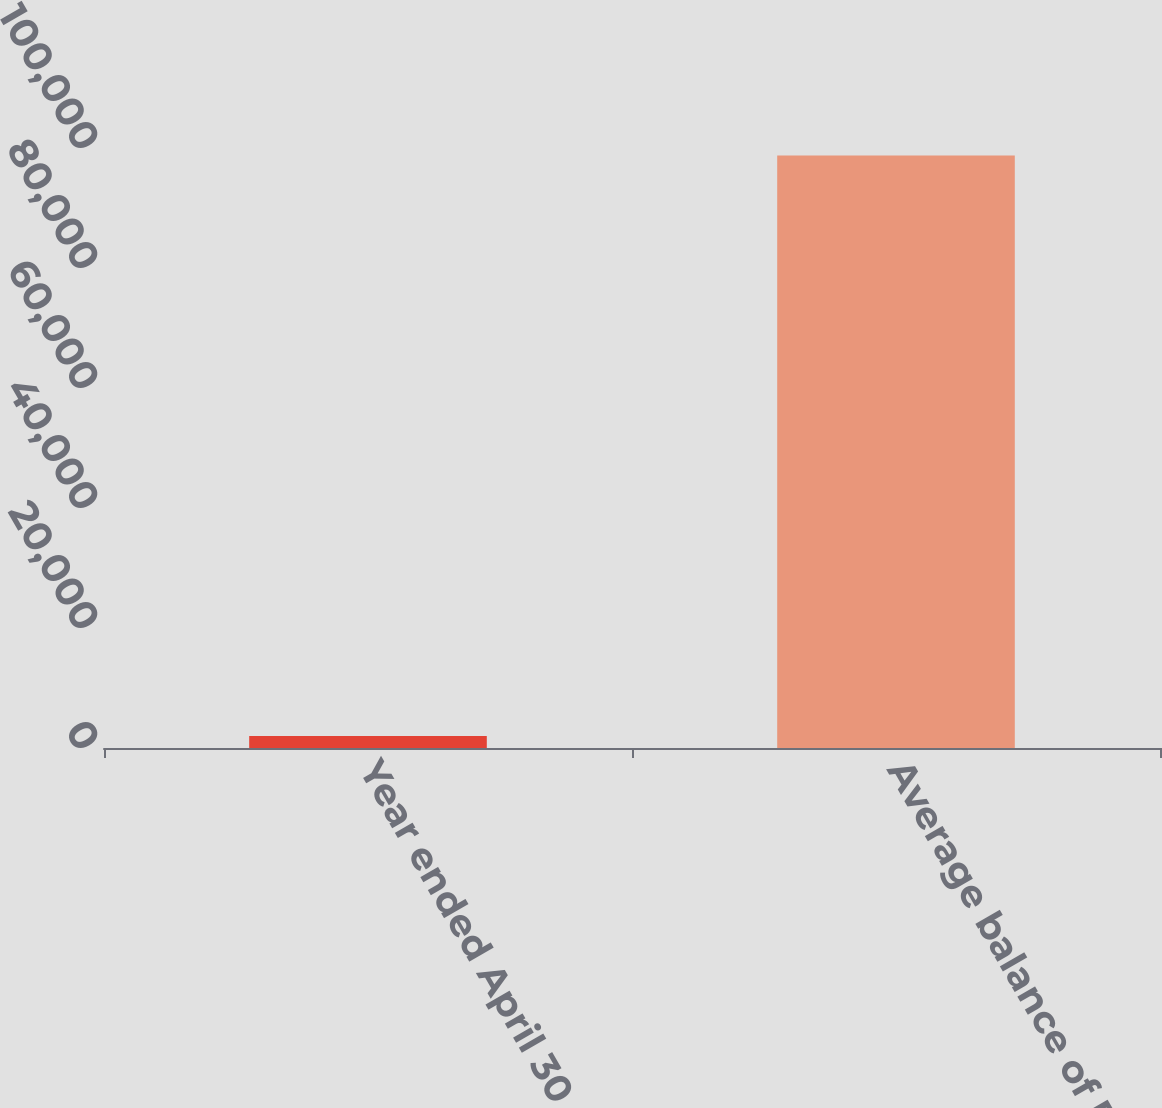Convert chart to OTSL. <chart><loc_0><loc_0><loc_500><loc_500><bar_chart><fcel>Year ended April 30<fcel>Average balance of FHLB<nl><fcel>2010<fcel>98767<nl></chart> 